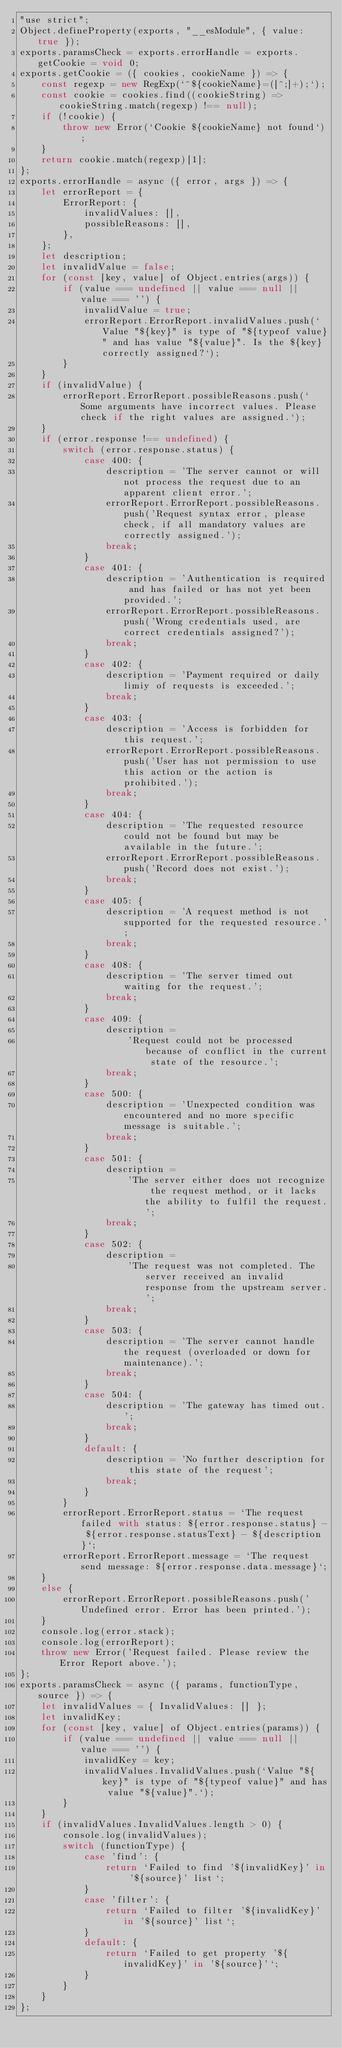Convert code to text. <code><loc_0><loc_0><loc_500><loc_500><_JavaScript_>"use strict";
Object.defineProperty(exports, "__esModule", { value: true });
exports.paramsCheck = exports.errorHandle = exports.getCookie = void 0;
exports.getCookie = ({ cookies, cookieName }) => {
    const regexp = new RegExp(`^${cookieName}=([^;]+);`);
    const cookie = cookies.find((cookieString) => cookieString.match(regexp) !== null);
    if (!cookie) {
        throw new Error(`Cookie ${cookieName} not found`);
    }
    return cookie.match(regexp)[1];
};
exports.errorHandle = async ({ error, args }) => {
    let errorReport = {
        ErrorReport: {
            invalidValues: [],
            possibleReasons: [],
        },
    };
    let description;
    let invalidValue = false;
    for (const [key, value] of Object.entries(args)) {
        if (value === undefined || value === null || value === '') {
            invalidValue = true;
            errorReport.ErrorReport.invalidValues.push(`Value "${key}" is type of "${typeof value}" and has value "${value}". Is the ${key} correctly assigned?`);
        }
    }
    if (invalidValue) {
        errorReport.ErrorReport.possibleReasons.push(`Some arguments have incorrect values. Please check if the right values are assigned.`);
    }
    if (error.response !== undefined) {
        switch (error.response.status) {
            case 400: {
                description = 'The server cannot or will not process the request due to an apparent client error.';
                errorReport.ErrorReport.possibleReasons.push('Request syntax error, please check, if all mandatory values are correctly assigned.');
                break;
            }
            case 401: {
                description = 'Authentication is required and has failed or has not yet been provided.';
                errorReport.ErrorReport.possibleReasons.push('Wrong credentials used, are correct credentials assigned?');
                break;
            }
            case 402: {
                description = 'Payment required or daily limiy of requests is exceeded.';
                break;
            }
            case 403: {
                description = 'Access is forbidden for this request.';
                errorReport.ErrorReport.possibleReasons.push('User has not permission to use this action or the action is prohibited.');
                break;
            }
            case 404: {
                description = 'The requested resource could not be found but may be available in the future.';
                errorReport.ErrorReport.possibleReasons.push('Record does not exist.');
                break;
            }
            case 405: {
                description = 'A request method is not supported for the requested resource.';
                break;
            }
            case 408: {
                description = 'The server timed out waiting for the request.';
                break;
            }
            case 409: {
                description =
                    'Request could not be processed because of conflict in the current state of the resource.';
                break;
            }
            case 500: {
                description = 'Unexpected condition was encountered and no more specific message is suitable.';
                break;
            }
            case 501: {
                description =
                    'The server either does not recognize the request method, or it lacks the ability to fulfil the request.';
                break;
            }
            case 502: {
                description =
                    'The request was not completed. The server received an invalid response from the upstream server.';
                break;
            }
            case 503: {
                description = 'The server cannot handle the request (overloaded or down for maintenance).';
                break;
            }
            case 504: {
                description = 'The gateway has timed out.';
                break;
            }
            default: {
                description = 'No further description for this state of the request';
                break;
            }
        }
        errorReport.ErrorReport.status = `The request failed with status: ${error.response.status} - ${error.response.statusText} - ${description}`;
        errorReport.ErrorReport.message = `The request send message: ${error.response.data.message}`;
    }
    else {
        errorReport.ErrorReport.possibleReasons.push('Undefined error. Error has been printed.');
    }
    console.log(error.stack);
    console.log(errorReport);
    throw new Error('Request failed. Please review the Error Report above.');
};
exports.paramsCheck = async ({ params, functionType, source }) => {
    let invalidValues = { InvalidValues: [] };
    let invalidKey;
    for (const [key, value] of Object.entries(params)) {
        if (value === undefined || value === null || value === '') {
            invalidKey = key;
            invalidValues.InvalidValues.push(`Value "${key}" is type of "${typeof value}" and has value "${value}".`);
        }
    }
    if (invalidValues.InvalidValues.length > 0) {
        console.log(invalidValues);
        switch (functionType) {
            case 'find': {
                return `Failed to find '${invalidKey}' in '${source}' list`;
            }
            case 'filter': {
                return `Failed to filter '${invalidKey}' in '${source}' list`;
            }
            default: {
                return `Failed to get property '${invalidKey}' in '${source}'`;
            }
        }
    }
};
</code> 